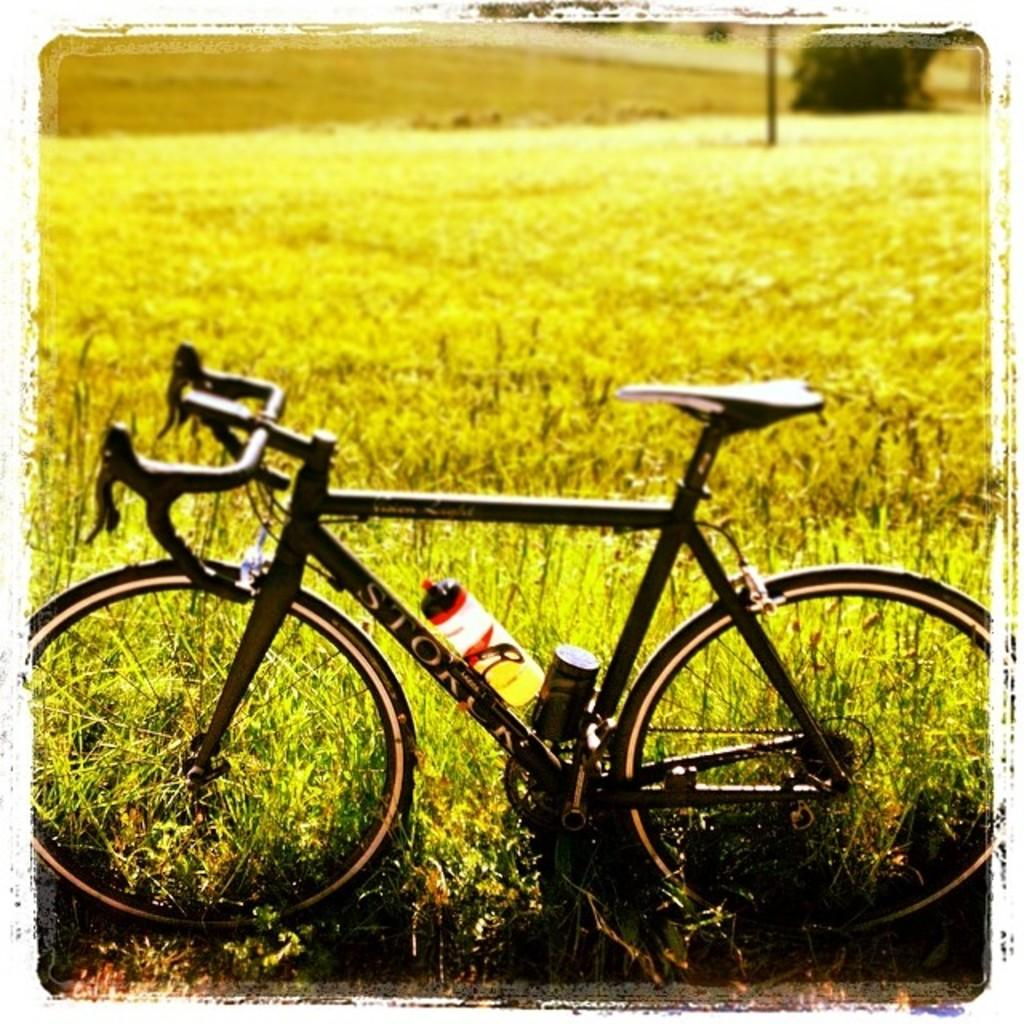What is the main object in the image? There is a cycle in the image. What is placed on the cycle? A water bottle is on the cycle. What can be seen in the background of the image? There is a farm behind the cycle. What objects are present in the farm? There is a metal pole and a tree in the farm. How many oranges are hanging from the tree in the image? There are no oranges present in the image; the tree in the farm does not have any oranges. Can you see an icicle hanging from the metal pole in the image? There is no icicle present in the image; the metal pole in the farm is not associated with any icicles. 